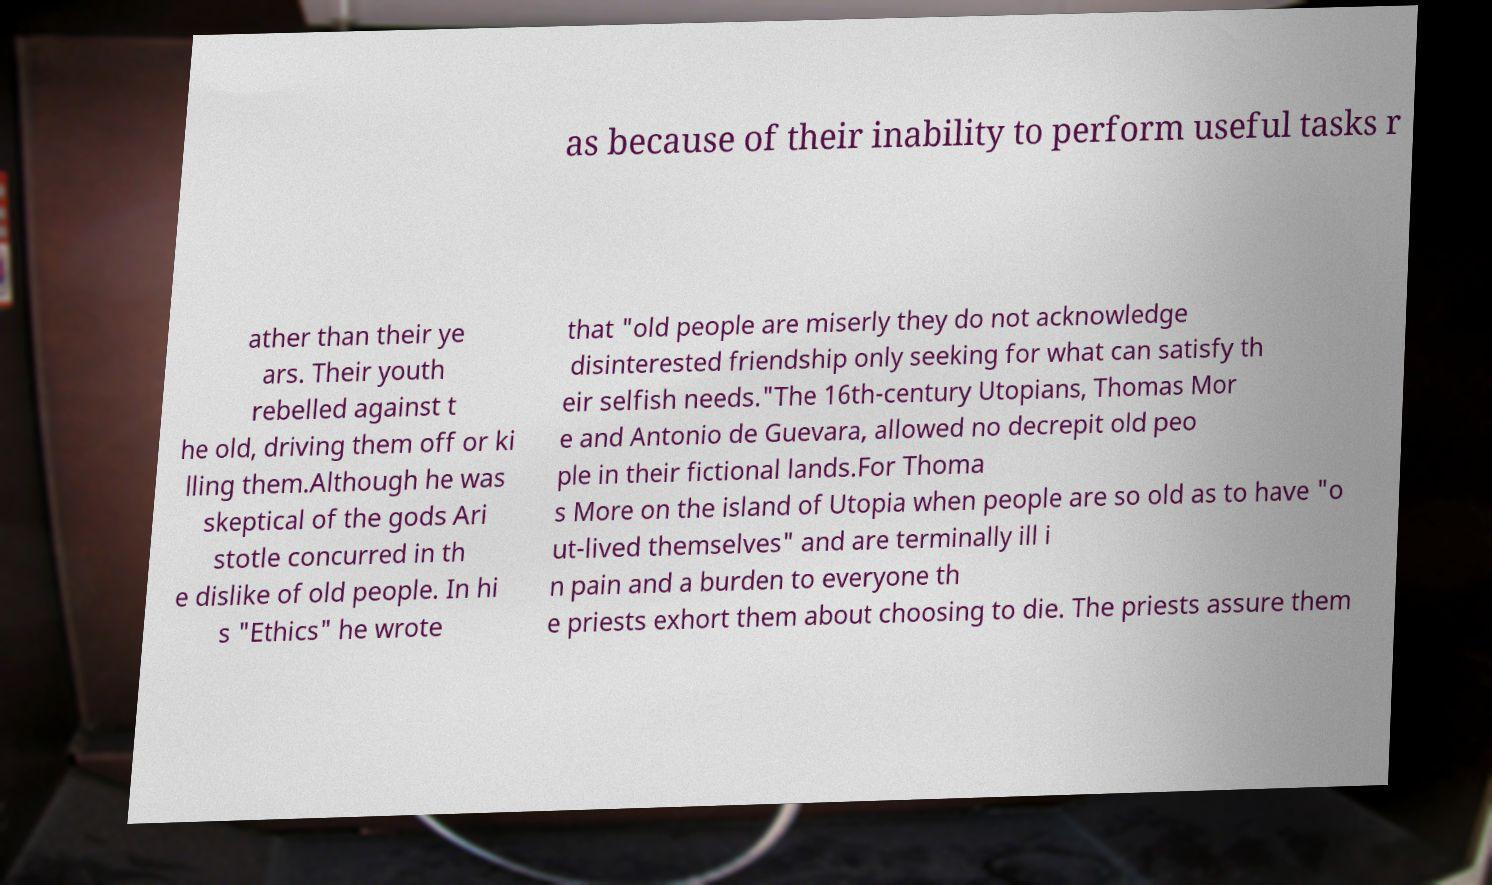Please identify and transcribe the text found in this image. as because of their inability to perform useful tasks r ather than their ye ars. Their youth rebelled against t he old, driving them off or ki lling them.Although he was skeptical of the gods Ari stotle concurred in th e dislike of old people. In hi s "Ethics" he wrote that "old people are miserly they do not acknowledge disinterested friendship only seeking for what can satisfy th eir selfish needs."The 16th-century Utopians, Thomas Mor e and Antonio de Guevara, allowed no decrepit old peo ple in their fictional lands.For Thoma s More on the island of Utopia when people are so old as to have "o ut-lived themselves" and are terminally ill i n pain and a burden to everyone th e priests exhort them about choosing to die. The priests assure them 